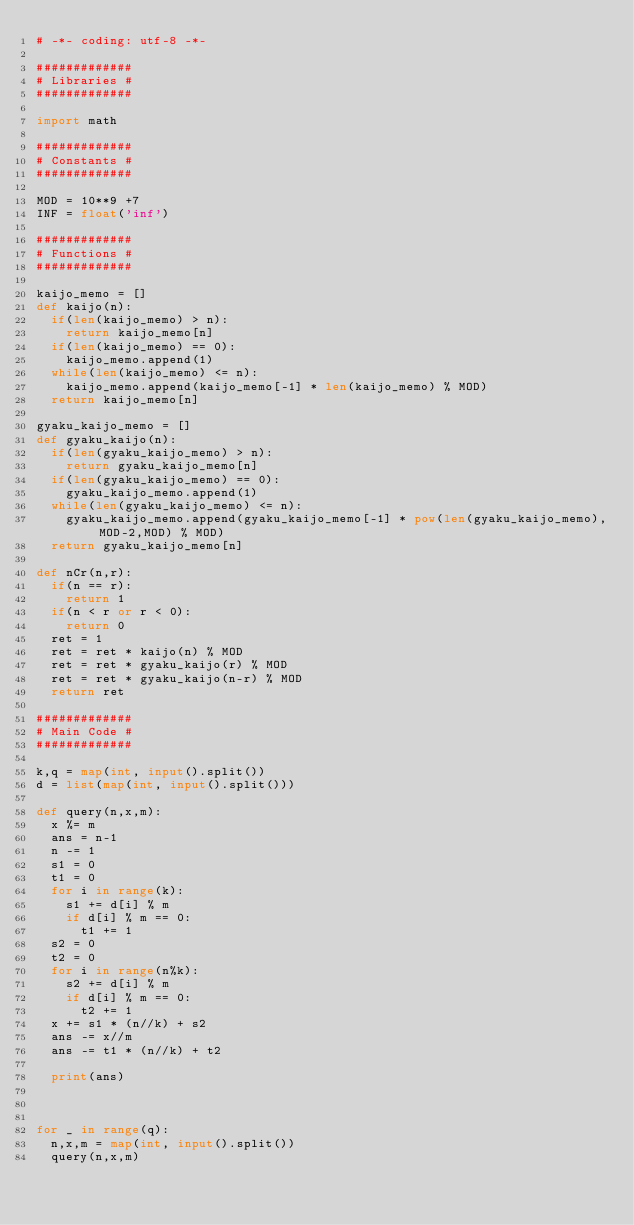<code> <loc_0><loc_0><loc_500><loc_500><_Python_># -*- coding: utf-8 -*-

#############
# Libraries #
#############

import math

#############
# Constants #
#############

MOD = 10**9 +7
INF = float('inf')

#############
# Functions #
#############

kaijo_memo = []
def kaijo(n):
  if(len(kaijo_memo) > n):
    return kaijo_memo[n]
  if(len(kaijo_memo) == 0):
    kaijo_memo.append(1)
  while(len(kaijo_memo) <= n):
    kaijo_memo.append(kaijo_memo[-1] * len(kaijo_memo) % MOD)
  return kaijo_memo[n]

gyaku_kaijo_memo = []
def gyaku_kaijo(n):
  if(len(gyaku_kaijo_memo) > n):
    return gyaku_kaijo_memo[n]
  if(len(gyaku_kaijo_memo) == 0):
    gyaku_kaijo_memo.append(1)
  while(len(gyaku_kaijo_memo) <= n):
    gyaku_kaijo_memo.append(gyaku_kaijo_memo[-1] * pow(len(gyaku_kaijo_memo),MOD-2,MOD) % MOD)
  return gyaku_kaijo_memo[n]

def nCr(n,r):
  if(n == r):
    return 1
  if(n < r or r < 0):
    return 0
  ret = 1
  ret = ret * kaijo(n) % MOD
  ret = ret * gyaku_kaijo(r) % MOD
  ret = ret * gyaku_kaijo(n-r) % MOD
  return ret

#############
# Main Code #
#############

k,q = map(int, input().split())
d = list(map(int, input().split()))

def query(n,x,m):
  x %= m
  ans = n-1
  n -= 1
  s1 = 0
  t1 = 0
  for i in range(k):
    s1 += d[i] % m
    if d[i] % m == 0:
      t1 += 1
  s2 = 0
  t2 = 0
  for i in range(n%k):
    s2 += d[i] % m
    if d[i] % m == 0:
      t2 += 1
  x += s1 * (n//k) + s2
  ans -= x//m
  ans -= t1 * (n//k) + t2
  
  print(ans)
  
    

for _ in range(q):
  n,x,m = map(int, input().split())
  query(n,x,m)
</code> 